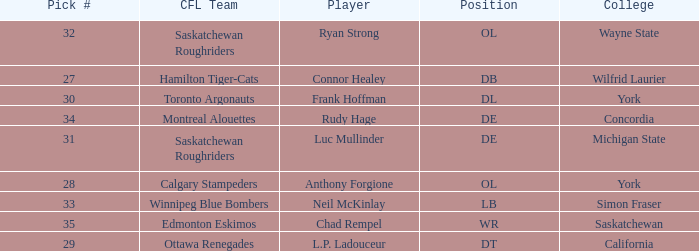What is the Pick # for the Edmonton Eskimos? 1.0. 